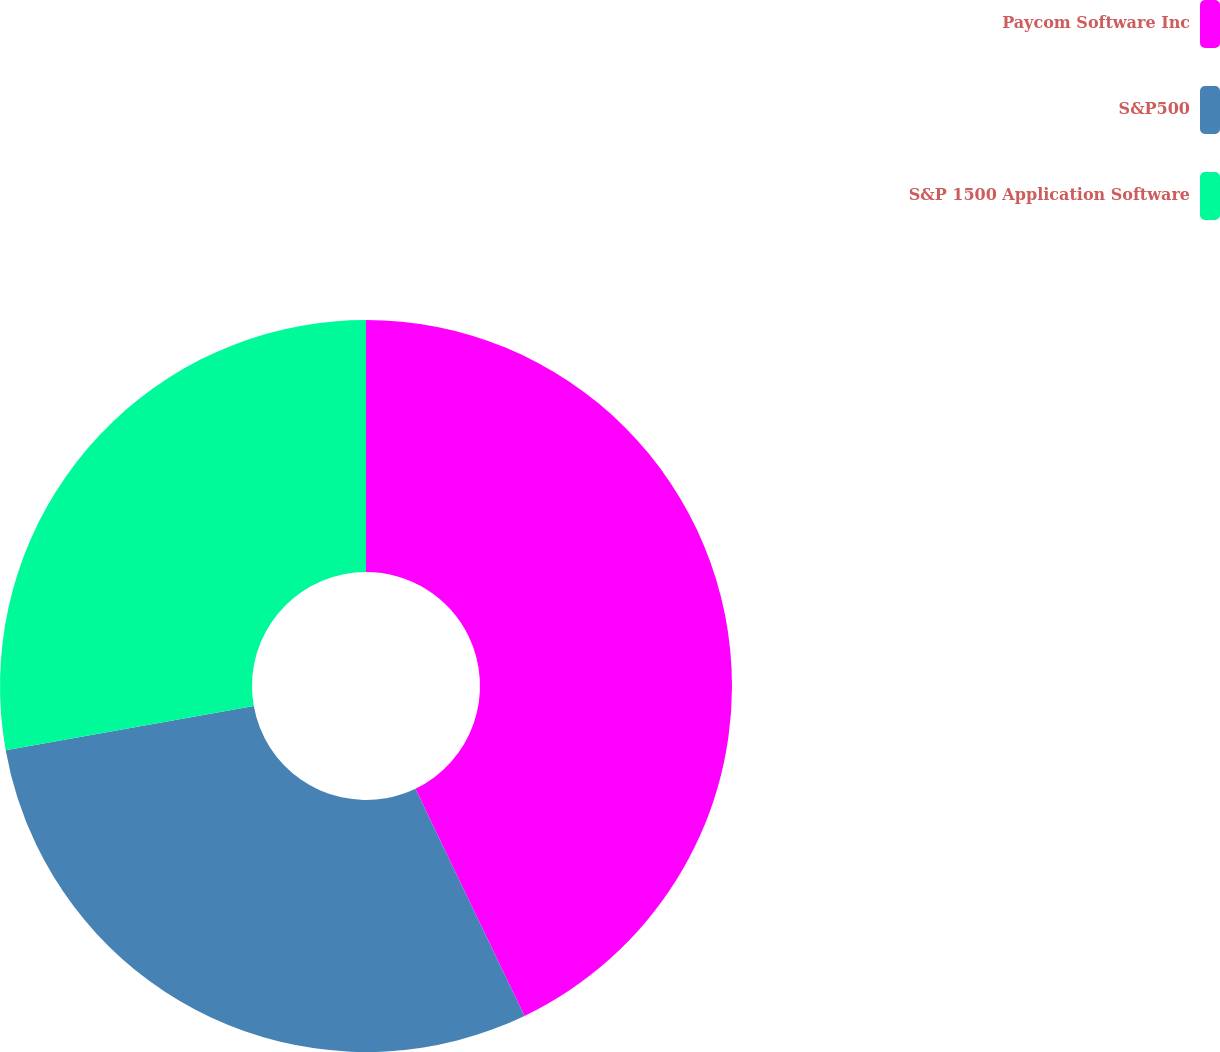Convert chart. <chart><loc_0><loc_0><loc_500><loc_500><pie_chart><fcel>Paycom Software Inc<fcel>S&P500<fcel>S&P 1500 Application Software<nl><fcel>42.87%<fcel>29.32%<fcel>27.81%<nl></chart> 